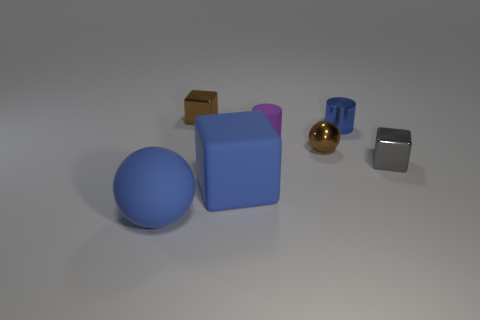Could you speculate on the purpose of these objects being grouped together? The grouping of objects in the image seems intentional, possibly for a compositional study of shapes, colors, and materials. One could theorize that this arrangement has been curated to contrast the differing surfaces, from matte to reflective, and the diverse geometric forms ranging from spherical to cuboidal. What do you think could be a practical application for these objects? These objects could be used in an instructional setting, such as a classroom, to teach concepts of geometry, materials science, or the physics of light and reflection. Alternatively, they might serve as props in a photography shoot to explore lighting effects on different surfaces and colors. 